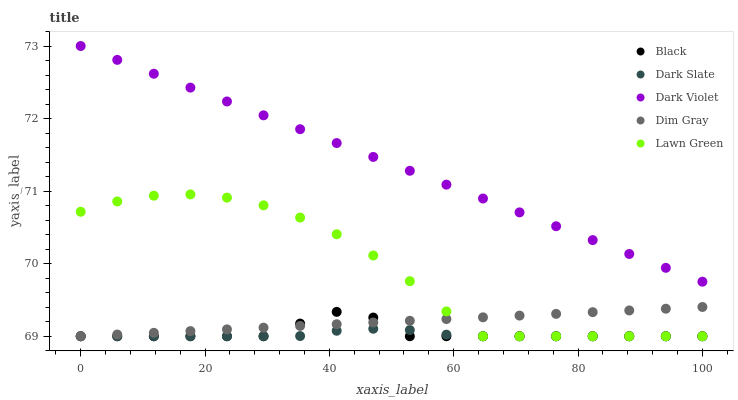Does Dark Slate have the minimum area under the curve?
Answer yes or no. Yes. Does Dark Violet have the maximum area under the curve?
Answer yes or no. Yes. Does Dim Gray have the minimum area under the curve?
Answer yes or no. No. Does Dim Gray have the maximum area under the curve?
Answer yes or no. No. Is Dark Violet the smoothest?
Answer yes or no. Yes. Is Lawn Green the roughest?
Answer yes or no. Yes. Is Dim Gray the smoothest?
Answer yes or no. No. Is Dim Gray the roughest?
Answer yes or no. No. Does Dark Slate have the lowest value?
Answer yes or no. Yes. Does Dark Violet have the lowest value?
Answer yes or no. No. Does Dark Violet have the highest value?
Answer yes or no. Yes. Does Dim Gray have the highest value?
Answer yes or no. No. Is Lawn Green less than Dark Violet?
Answer yes or no. Yes. Is Dark Violet greater than Lawn Green?
Answer yes or no. Yes. Does Dim Gray intersect Lawn Green?
Answer yes or no. Yes. Is Dim Gray less than Lawn Green?
Answer yes or no. No. Is Dim Gray greater than Lawn Green?
Answer yes or no. No. Does Lawn Green intersect Dark Violet?
Answer yes or no. No. 